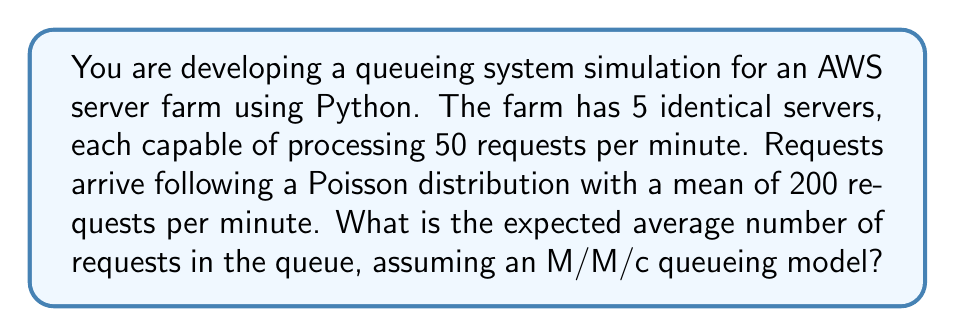Can you solve this math problem? Let's approach this step-by-step using the M/M/c queueing model:

1. Define the parameters:
   $\lambda$ = arrival rate = 200 requests/minute
   $\mu$ = service rate per server = 50 requests/minute
   $c$ = number of servers = 5

2. Calculate the utilization factor $\rho$:
   $$\rho = \frac{\lambda}{c\mu} = \frac{200}{5 \cdot 50} = 0.8$$

3. Calculate $P_0$, the probability of an empty system:
   $$P_0 = \left[\sum_{n=0}^{c-1}\frac{(c\rho)^n}{n!} + \frac{(c\rho)^c}{c!(1-\rho)}\right]^{-1}$$
   
   Using Python to calculate this:
   ```python
   import math
   
   c = 5
   rho = 0.8
   
   sum_term = sum((c*rho)**n / math.factorial(n) for n in range(c))
   last_term = (c*rho)**c / (math.factorial(c) * (1-rho))
   
   P0 = 1 / (sum_term + last_term)
   ```
   
   This gives us $P_0 \approx 0.0132$

4. Calculate $L_q$, the expected number of requests in the queue:
   $$L_q = \frac{P_0(c\rho)^c\rho}{c!(1-\rho)^2}$$
   
   Plugging in the values:
   $$L_q = \frac{0.0132 \cdot (5 \cdot 0.8)^5 \cdot 0.8}{5!(1-0.8)^2} \approx 12.8$$

Therefore, the expected average number of requests in the queue is approximately 12.8.
Answer: 12.8 requests 